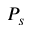Convert formula to latex. <formula><loc_0><loc_0><loc_500><loc_500>P _ { s }</formula> 